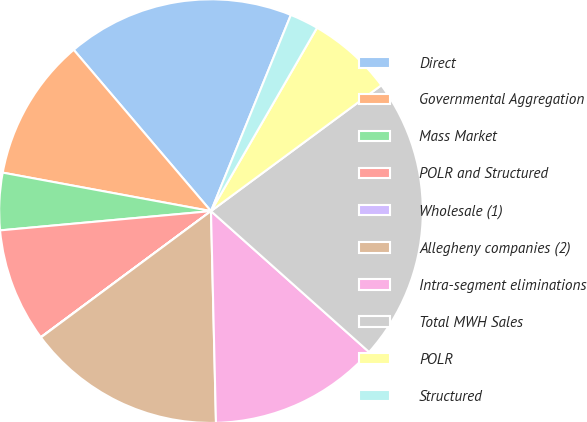Convert chart to OTSL. <chart><loc_0><loc_0><loc_500><loc_500><pie_chart><fcel>Direct<fcel>Governmental Aggregation<fcel>Mass Market<fcel>POLR and Structured<fcel>Wholesale (1)<fcel>Allegheny companies (2)<fcel>Intra-segment eliminations<fcel>Total MWH Sales<fcel>POLR<fcel>Structured<nl><fcel>17.38%<fcel>10.87%<fcel>4.36%<fcel>8.7%<fcel>0.02%<fcel>15.21%<fcel>13.04%<fcel>21.72%<fcel>6.53%<fcel>2.19%<nl></chart> 